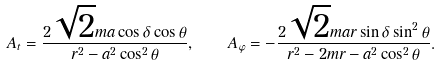<formula> <loc_0><loc_0><loc_500><loc_500>A _ { t } = { \frac { 2 \sqrt { 2 } m a \cos \delta \cos \theta } { r ^ { 2 } - a ^ { 2 } \cos ^ { 2 } \theta } } , \quad A _ { \varphi } = - { \frac { 2 \sqrt { 2 } m a r \sin \delta \sin ^ { 2 } \theta } { r ^ { 2 } - 2 m r - a ^ { 2 } \cos ^ { 2 } \theta } } .</formula> 